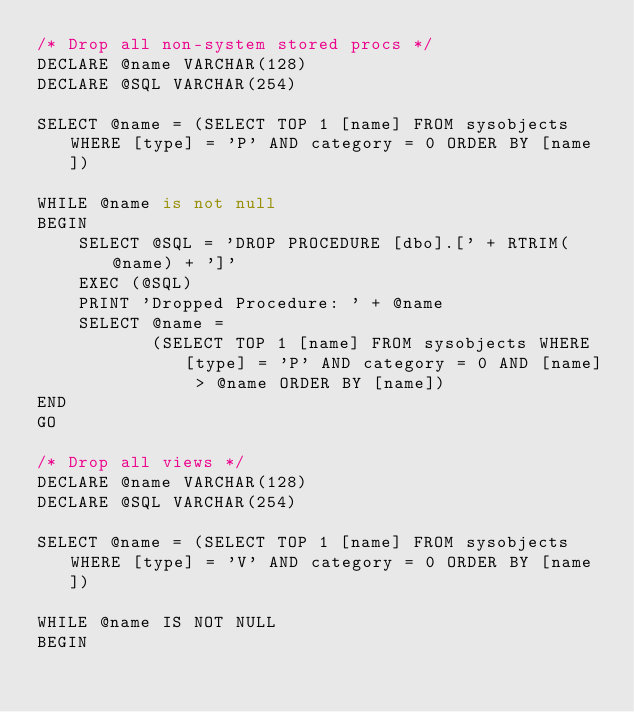<code> <loc_0><loc_0><loc_500><loc_500><_SQL_>/* Drop all non-system stored procs */
DECLARE @name VARCHAR(128)
DECLARE @SQL VARCHAR(254)

SELECT @name = (SELECT TOP 1 [name] FROM sysobjects WHERE [type] = 'P' AND category = 0 ORDER BY [name])

WHILE @name is not null
BEGIN
    SELECT @SQL = 'DROP PROCEDURE [dbo].[' + RTRIM(@name) + ']'
    EXEC (@SQL)
    PRINT 'Dropped Procedure: ' + @name
    SELECT @name =
           (SELECT TOP 1 [name] FROM sysobjects WHERE [type] = 'P' AND category = 0 AND [name] > @name ORDER BY [name])
END
GO

/* Drop all views */
DECLARE @name VARCHAR(128)
DECLARE @SQL VARCHAR(254)

SELECT @name = (SELECT TOP 1 [name] FROM sysobjects WHERE [type] = 'V' AND category = 0 ORDER BY [name])

WHILE @name IS NOT NULL
BEGIN</code> 